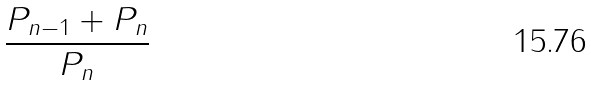<formula> <loc_0><loc_0><loc_500><loc_500>\frac { P _ { n - 1 } + P _ { n } } { P _ { n } }</formula> 